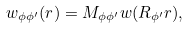Convert formula to latex. <formula><loc_0><loc_0><loc_500><loc_500>w _ { \phi \phi ^ { \prime } } ( { r } ) = M _ { \phi \phi ^ { \prime } } w ( R _ { \phi ^ { \prime } } { r } ) ,</formula> 